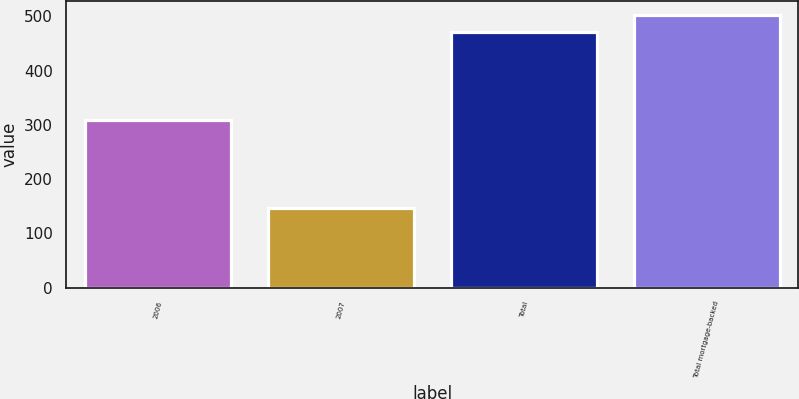Convert chart to OTSL. <chart><loc_0><loc_0><loc_500><loc_500><bar_chart><fcel>2006<fcel>2007<fcel>Total<fcel>Total mortgage-backed<nl><fcel>309<fcel>147<fcel>471<fcel>503.4<nl></chart> 